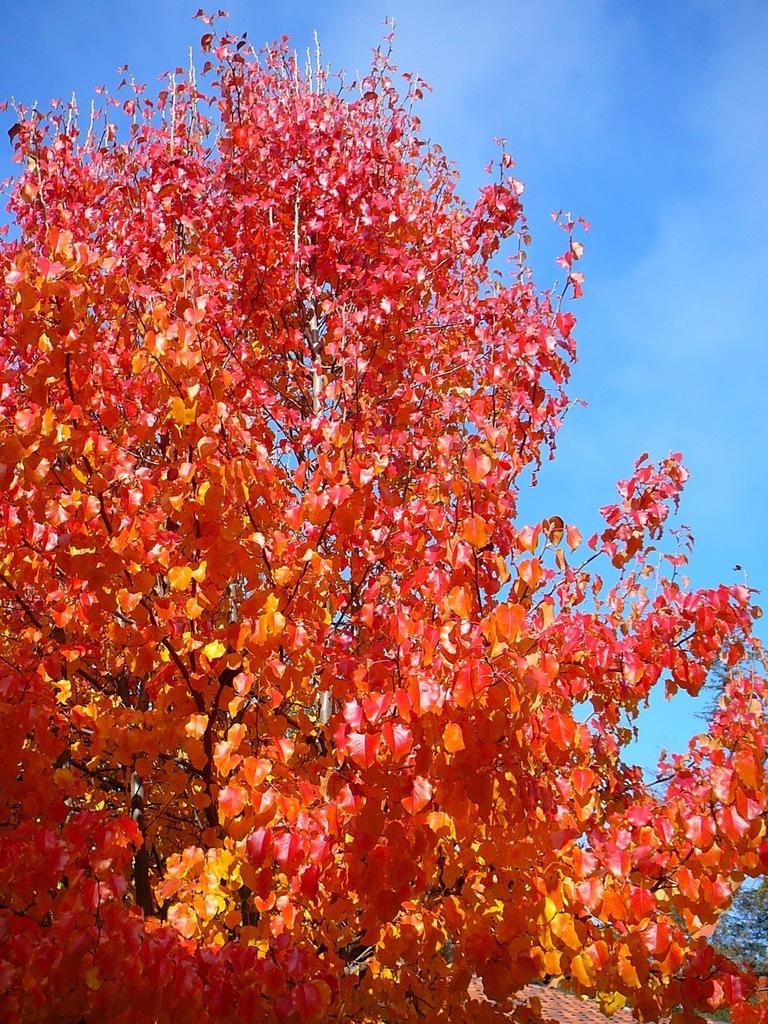What type of plant can be seen in the image? There is a tree in the image. What can be seen in the background of the image? The sky is visible in the background of the image. Where is the rose placed on the shelf in the image? There is no rose or shelf present in the image. What advice does the father give to the child in the image? There is no father or child present in the image. 